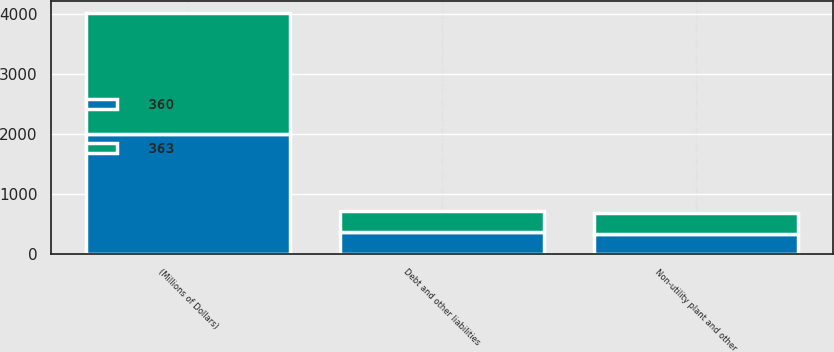<chart> <loc_0><loc_0><loc_500><loc_500><stacked_bar_chart><ecel><fcel>(Millions of Dollars)<fcel>Non-utility plant and other<fcel>Debt and other liabilities<nl><fcel>360<fcel>2005<fcel>338<fcel>360<nl><fcel>363<fcel>2004<fcel>347<fcel>363<nl></chart> 